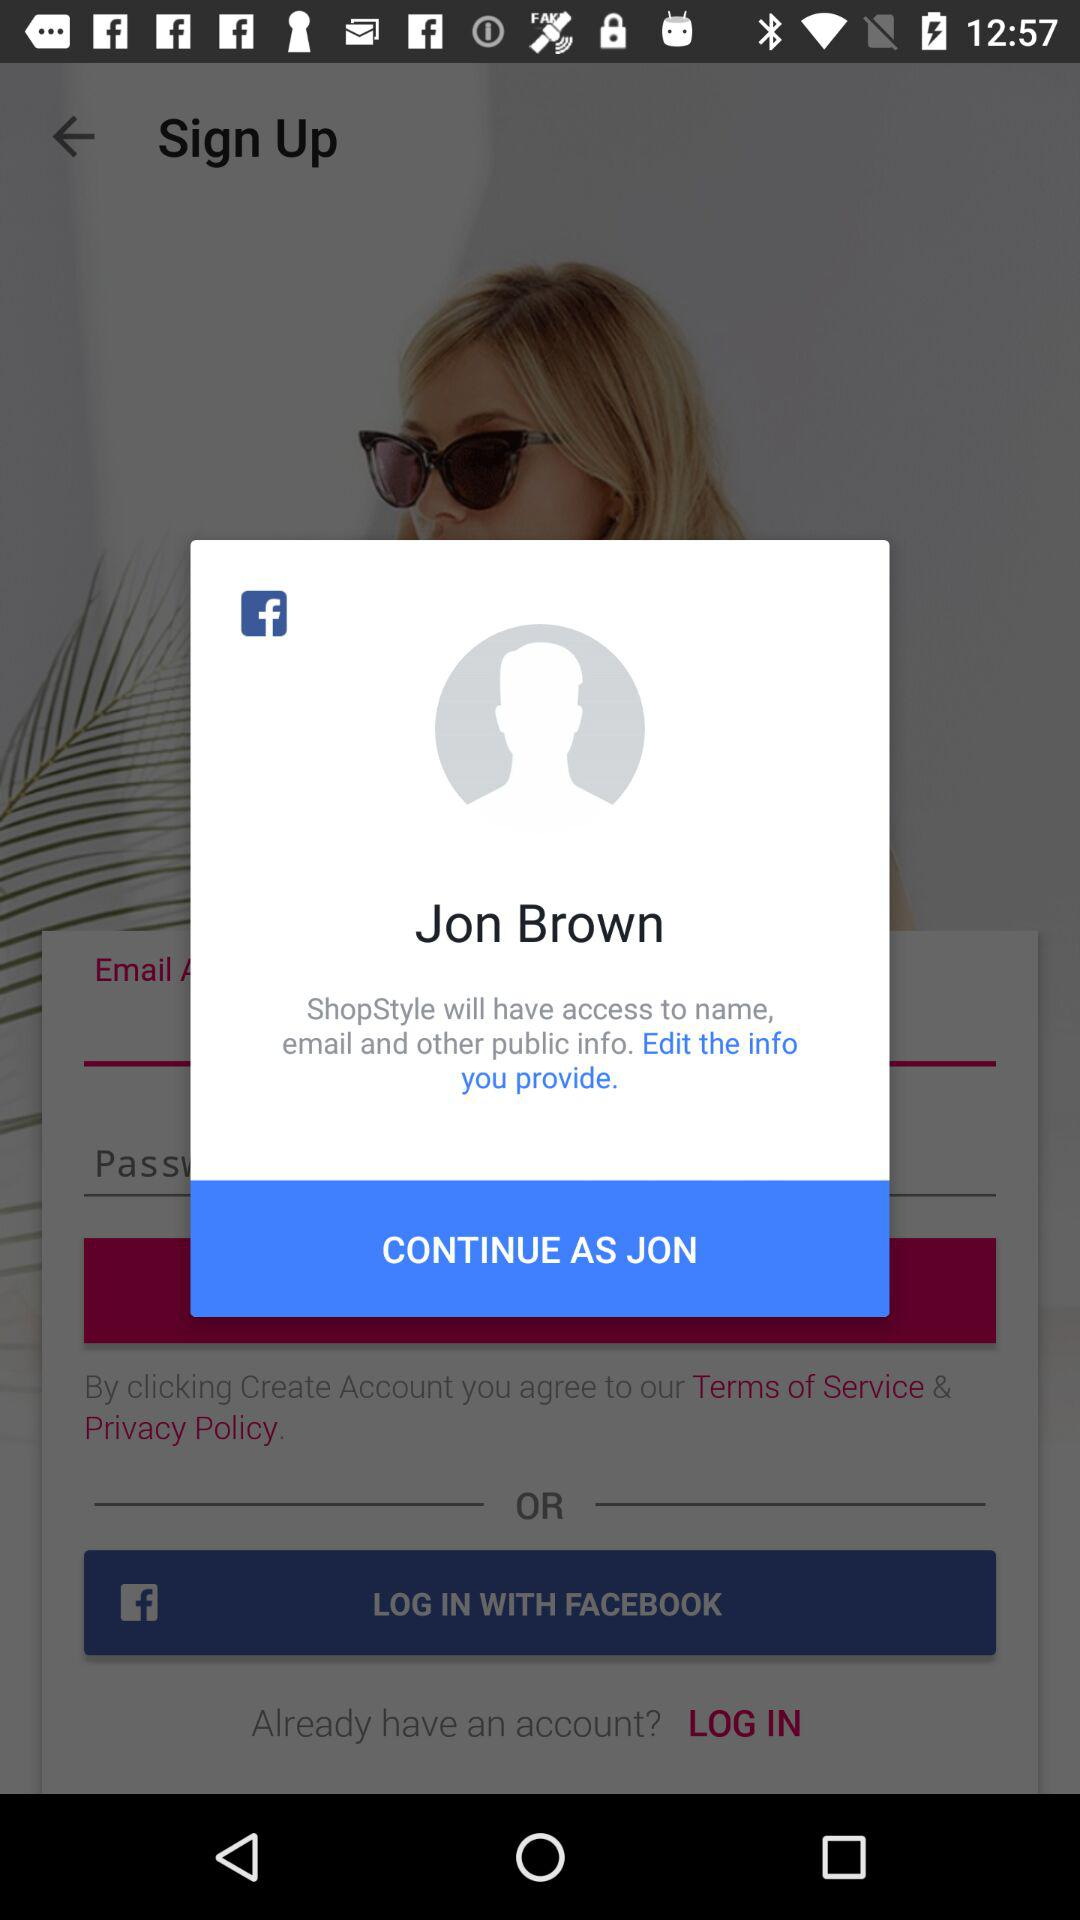What application has asked for permission? The application that has asked for permission is "ShopStyle". 